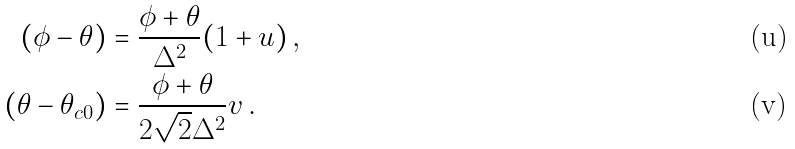Convert formula to latex. <formula><loc_0><loc_0><loc_500><loc_500>( \phi - \theta ) & = \frac { \phi + \theta } { \Delta ^ { 2 } } ( 1 + u ) \, , \\ ( \theta - \theta _ { c 0 } ) & = \frac { \phi + \theta } { 2 \sqrt { 2 } \Delta ^ { 2 } } v \, .</formula> 